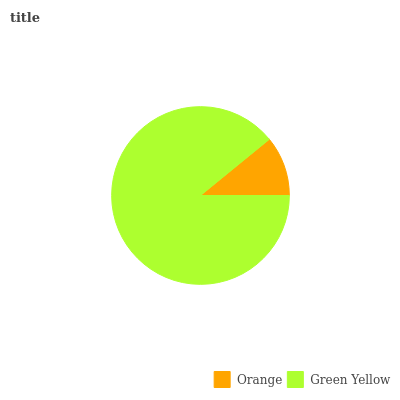Is Orange the minimum?
Answer yes or no. Yes. Is Green Yellow the maximum?
Answer yes or no. Yes. Is Green Yellow the minimum?
Answer yes or no. No. Is Green Yellow greater than Orange?
Answer yes or no. Yes. Is Orange less than Green Yellow?
Answer yes or no. Yes. Is Orange greater than Green Yellow?
Answer yes or no. No. Is Green Yellow less than Orange?
Answer yes or no. No. Is Green Yellow the high median?
Answer yes or no. Yes. Is Orange the low median?
Answer yes or no. Yes. Is Orange the high median?
Answer yes or no. No. Is Green Yellow the low median?
Answer yes or no. No. 